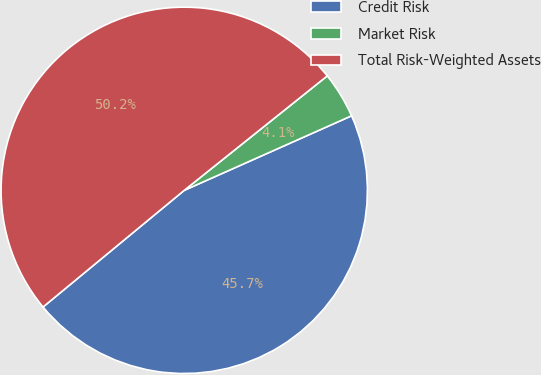Convert chart to OTSL. <chart><loc_0><loc_0><loc_500><loc_500><pie_chart><fcel>Credit Risk<fcel>Market Risk<fcel>Total Risk-Weighted Assets<nl><fcel>45.68%<fcel>4.07%<fcel>50.25%<nl></chart> 